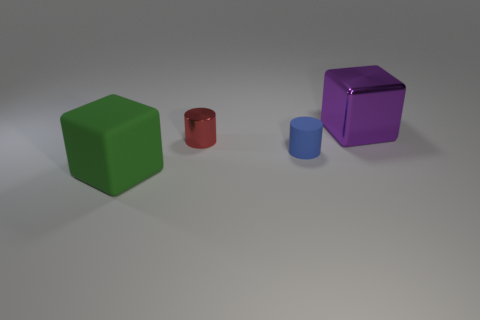Add 1 tiny brown spheres. How many objects exist? 5 Add 4 purple shiny objects. How many purple shiny objects are left? 5 Add 4 shiny cylinders. How many shiny cylinders exist? 5 Subtract all red cylinders. How many cylinders are left? 1 Subtract 0 green cylinders. How many objects are left? 4 Subtract 2 cylinders. How many cylinders are left? 0 Subtract all green cubes. Subtract all green balls. How many cubes are left? 1 Subtract all yellow spheres. How many green blocks are left? 1 Subtract all metallic objects. Subtract all small matte cylinders. How many objects are left? 1 